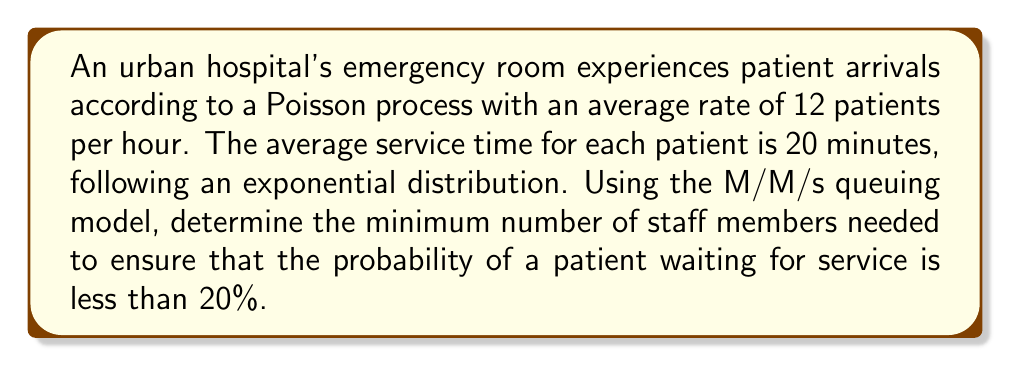Help me with this question. To solve this problem, we'll use the M/M/s queuing model and follow these steps:

1. Define the parameters:
   $\lambda$ = arrival rate = 12 patients/hour
   $\mu$ = service rate = 3 patients/hour (60 minutes / 20 minutes)
   $\rho$ = utilization factor = $\lambda / (s\mu)$, where $s$ is the number of servers (staff members)

2. We need to find the minimum value of $s$ that satisfies:
   $P_w < 0.20$, where $P_w$ is the probability of waiting

3. For an M/M/s queue, the probability of waiting is given by:

   $$P_w = \frac{(s\rho)^s}{s!(1-\rho)} \cdot P_0$$

   where $P_0$ is the probability of an empty system:

   $$P_0 = \left[\sum_{n=0}^{s-1}\frac{(s\rho)^n}{n!} + \frac{(s\rho)^s}{s!(1-\rho)}\right]^{-1}$$

4. We'll start with $s=4$ and increment until we find a value that satisfies $P_w < 0.20$:

   For $s=4$:
   $\rho = 12 / (4 * 3) = 1$ (system is unstable)

   For $s=5$:
   $\rho = 12 / (5 * 3) = 0.8$
   $P_0 \approx 0.0132$
   $P_w \approx 0.7494 > 0.20$

   For $s=6$:
   $\rho = 12 / (6 * 3) = 0.6667$
   $P_0 \approx 0.0278$
   $P_w \approx 0.4561 > 0.20$

   For $s=7$:
   $\rho = 12 / (7 * 3) = 0.5714$
   $P_0 \approx 0.0406$
   $P_w \approx 0.2451 > 0.20$

   For $s=8$:
   $\rho = 12 / (8 * 3) = 0.5$
   $P_0 \approx 0.0500$
   $P_w \approx 0.1172 < 0.20$

5. Therefore, the minimum number of staff members needed is 8.
Answer: 8 staff members 